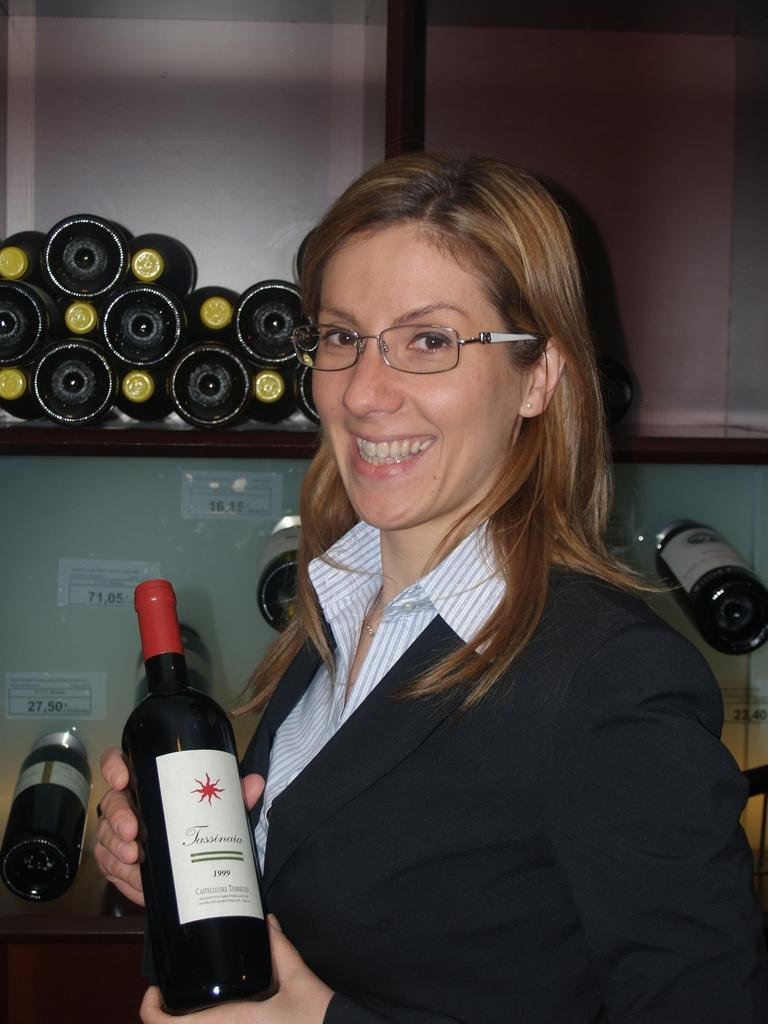Who is present in the image? There is a woman in the image. What is the woman doing in the image? The woman is smiling in the image. What object is the woman holding in her hands? The woman is holding a wine bottle in her hands. What can be seen in the background of the image? There are bottles visible in a cupboard in the background. What type of cattle can be seen sleeping on the bed in the image? There is no bed or cattle present in the image. What attraction is the woman visiting in the image? The image does not show the woman visiting any attraction; it only shows her holding a wine bottle and smiling. 